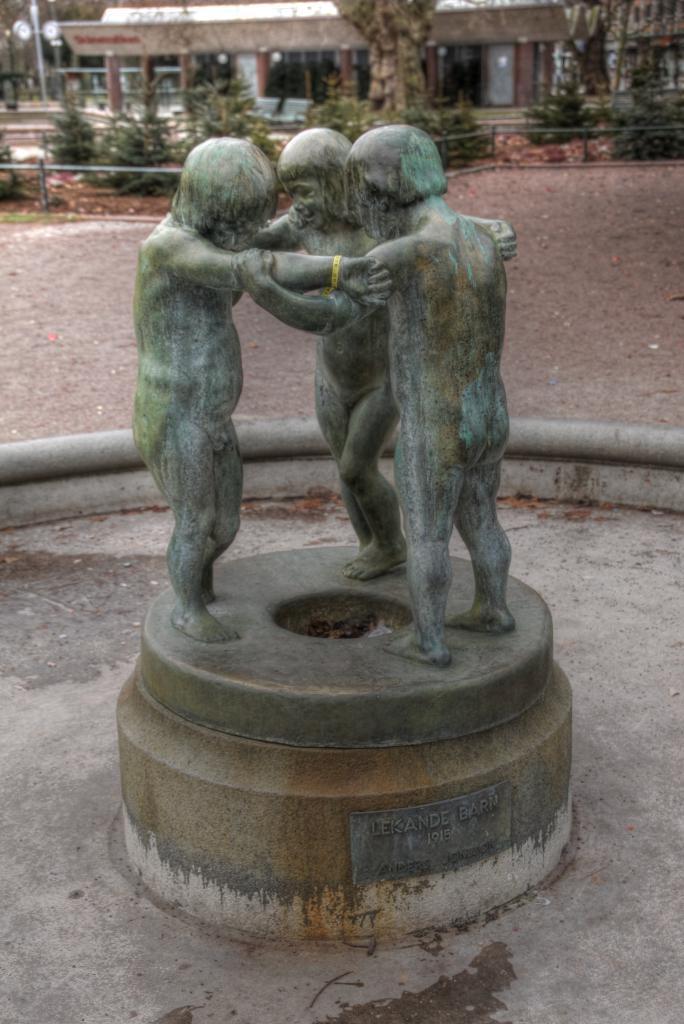Can you describe this image briefly? There is a statue at the bottom of this image and there are some trees and a building in the background. 